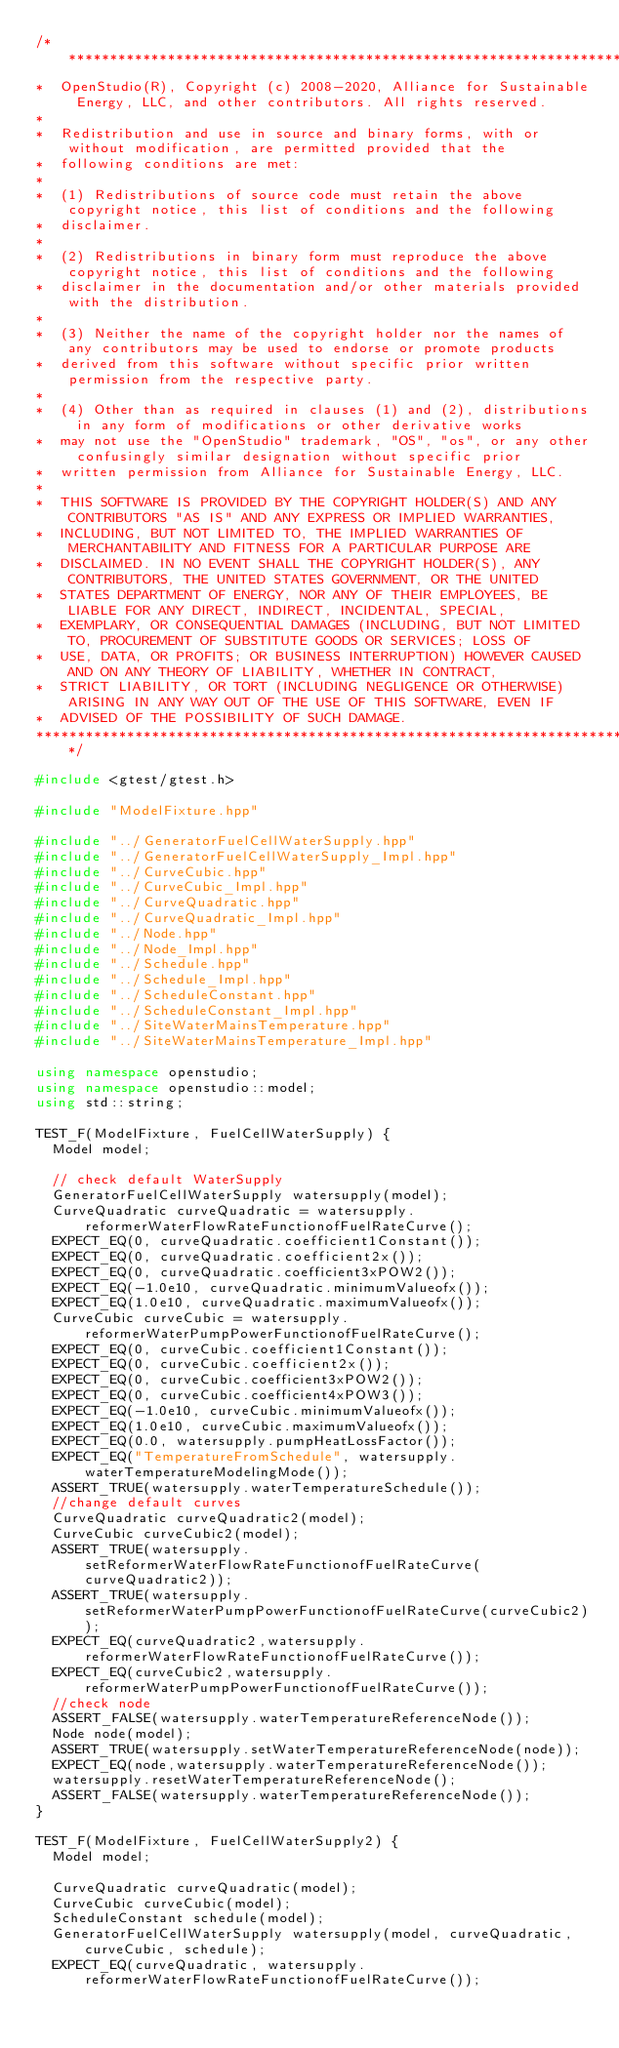<code> <loc_0><loc_0><loc_500><loc_500><_C++_>/***********************************************************************************************************************
*  OpenStudio(R), Copyright (c) 2008-2020, Alliance for Sustainable Energy, LLC, and other contributors. All rights reserved.
*
*  Redistribution and use in source and binary forms, with or without modification, are permitted provided that the
*  following conditions are met:
*
*  (1) Redistributions of source code must retain the above copyright notice, this list of conditions and the following
*  disclaimer.
*
*  (2) Redistributions in binary form must reproduce the above copyright notice, this list of conditions and the following
*  disclaimer in the documentation and/or other materials provided with the distribution.
*
*  (3) Neither the name of the copyright holder nor the names of any contributors may be used to endorse or promote products
*  derived from this software without specific prior written permission from the respective party.
*
*  (4) Other than as required in clauses (1) and (2), distributions in any form of modifications or other derivative works
*  may not use the "OpenStudio" trademark, "OS", "os", or any other confusingly similar designation without specific prior
*  written permission from Alliance for Sustainable Energy, LLC.
*
*  THIS SOFTWARE IS PROVIDED BY THE COPYRIGHT HOLDER(S) AND ANY CONTRIBUTORS "AS IS" AND ANY EXPRESS OR IMPLIED WARRANTIES,
*  INCLUDING, BUT NOT LIMITED TO, THE IMPLIED WARRANTIES OF MERCHANTABILITY AND FITNESS FOR A PARTICULAR PURPOSE ARE
*  DISCLAIMED. IN NO EVENT SHALL THE COPYRIGHT HOLDER(S), ANY CONTRIBUTORS, THE UNITED STATES GOVERNMENT, OR THE UNITED
*  STATES DEPARTMENT OF ENERGY, NOR ANY OF THEIR EMPLOYEES, BE LIABLE FOR ANY DIRECT, INDIRECT, INCIDENTAL, SPECIAL,
*  EXEMPLARY, OR CONSEQUENTIAL DAMAGES (INCLUDING, BUT NOT LIMITED TO, PROCUREMENT OF SUBSTITUTE GOODS OR SERVICES; LOSS OF
*  USE, DATA, OR PROFITS; OR BUSINESS INTERRUPTION) HOWEVER CAUSED AND ON ANY THEORY OF LIABILITY, WHETHER IN CONTRACT,
*  STRICT LIABILITY, OR TORT (INCLUDING NEGLIGENCE OR OTHERWISE) ARISING IN ANY WAY OUT OF THE USE OF THIS SOFTWARE, EVEN IF
*  ADVISED OF THE POSSIBILITY OF SUCH DAMAGE.
***********************************************************************************************************************/

#include <gtest/gtest.h>

#include "ModelFixture.hpp"

#include "../GeneratorFuelCellWaterSupply.hpp"
#include "../GeneratorFuelCellWaterSupply_Impl.hpp"
#include "../CurveCubic.hpp"
#include "../CurveCubic_Impl.hpp"
#include "../CurveQuadratic.hpp"
#include "../CurveQuadratic_Impl.hpp"
#include "../Node.hpp"
#include "../Node_Impl.hpp"
#include "../Schedule.hpp"
#include "../Schedule_Impl.hpp"
#include "../ScheduleConstant.hpp"
#include "../ScheduleConstant_Impl.hpp"
#include "../SiteWaterMainsTemperature.hpp"
#include "../SiteWaterMainsTemperature_Impl.hpp"

using namespace openstudio;
using namespace openstudio::model;
using std::string;

TEST_F(ModelFixture, FuelCellWaterSupply) {
  Model model;

  // check default WaterSupply
  GeneratorFuelCellWaterSupply watersupply(model);
  CurveQuadratic curveQuadratic = watersupply.reformerWaterFlowRateFunctionofFuelRateCurve();
  EXPECT_EQ(0, curveQuadratic.coefficient1Constant());
  EXPECT_EQ(0, curveQuadratic.coefficient2x());
  EXPECT_EQ(0, curveQuadratic.coefficient3xPOW2());
  EXPECT_EQ(-1.0e10, curveQuadratic.minimumValueofx());
  EXPECT_EQ(1.0e10, curveQuadratic.maximumValueofx());
  CurveCubic curveCubic = watersupply.reformerWaterPumpPowerFunctionofFuelRateCurve();
  EXPECT_EQ(0, curveCubic.coefficient1Constant());
  EXPECT_EQ(0, curveCubic.coefficient2x());
  EXPECT_EQ(0, curveCubic.coefficient3xPOW2());
  EXPECT_EQ(0, curveCubic.coefficient4xPOW3());
  EXPECT_EQ(-1.0e10, curveCubic.minimumValueofx());
  EXPECT_EQ(1.0e10, curveCubic.maximumValueofx());
  EXPECT_EQ(0.0, watersupply.pumpHeatLossFactor());
  EXPECT_EQ("TemperatureFromSchedule", watersupply.waterTemperatureModelingMode());
  ASSERT_TRUE(watersupply.waterTemperatureSchedule());
  //change default curves
  CurveQuadratic curveQuadratic2(model);
  CurveCubic curveCubic2(model);
  ASSERT_TRUE(watersupply.setReformerWaterFlowRateFunctionofFuelRateCurve(curveQuadratic2));
  ASSERT_TRUE(watersupply.setReformerWaterPumpPowerFunctionofFuelRateCurve(curveCubic2));
  EXPECT_EQ(curveQuadratic2,watersupply.reformerWaterFlowRateFunctionofFuelRateCurve());
  EXPECT_EQ(curveCubic2,watersupply.reformerWaterPumpPowerFunctionofFuelRateCurve());
  //check node
  ASSERT_FALSE(watersupply.waterTemperatureReferenceNode());
  Node node(model);
  ASSERT_TRUE(watersupply.setWaterTemperatureReferenceNode(node));
  EXPECT_EQ(node,watersupply.waterTemperatureReferenceNode());
  watersupply.resetWaterTemperatureReferenceNode();
  ASSERT_FALSE(watersupply.waterTemperatureReferenceNode());
}

TEST_F(ModelFixture, FuelCellWaterSupply2) {
  Model model;

  CurveQuadratic curveQuadratic(model);
  CurveCubic curveCubic(model);
  ScheduleConstant schedule(model);
  GeneratorFuelCellWaterSupply watersupply(model, curveQuadratic, curveCubic, schedule);
  EXPECT_EQ(curveQuadratic, watersupply.reformerWaterFlowRateFunctionofFuelRateCurve());</code> 